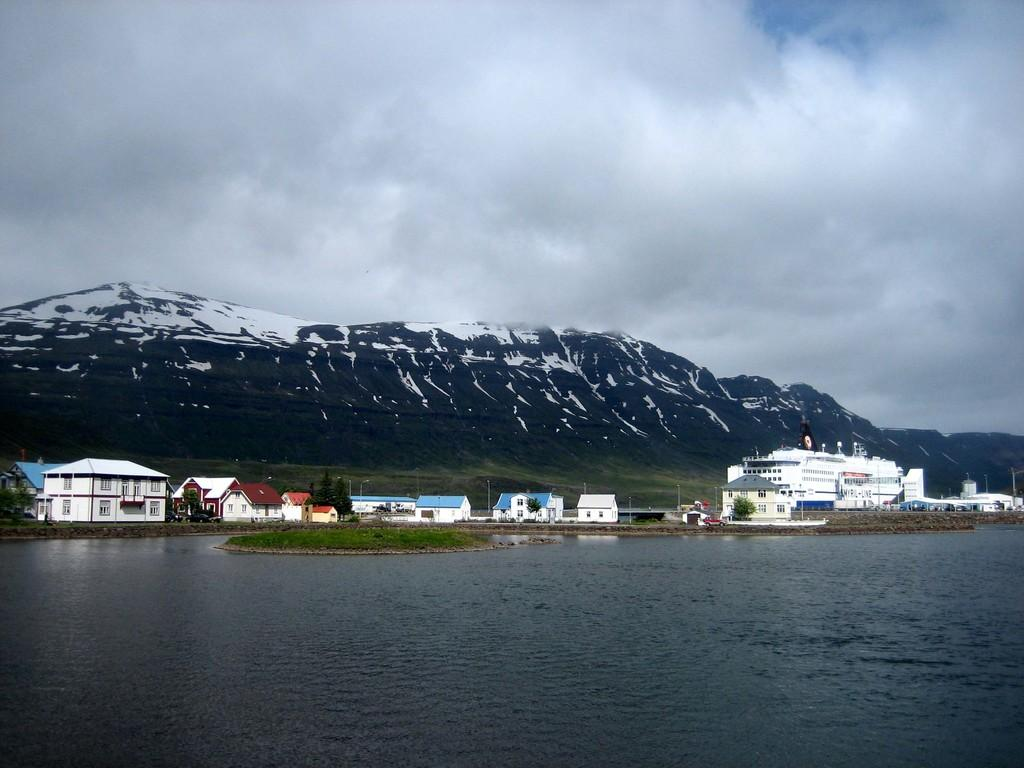What is the main element present in the image? There is water in the image. What other structures or objects can be seen in the image? There are houses, trees, and a white-colored ship on the right side of the image. What is visible in the background of the image? There are mountains and the sky visible in the background of the image. What type of bell is hanging from the ship in the image? There is no bell present on the ship in the image. Who is the representative of the houses in the image? The image does not depict any individuals or representatives associated with the houses. 